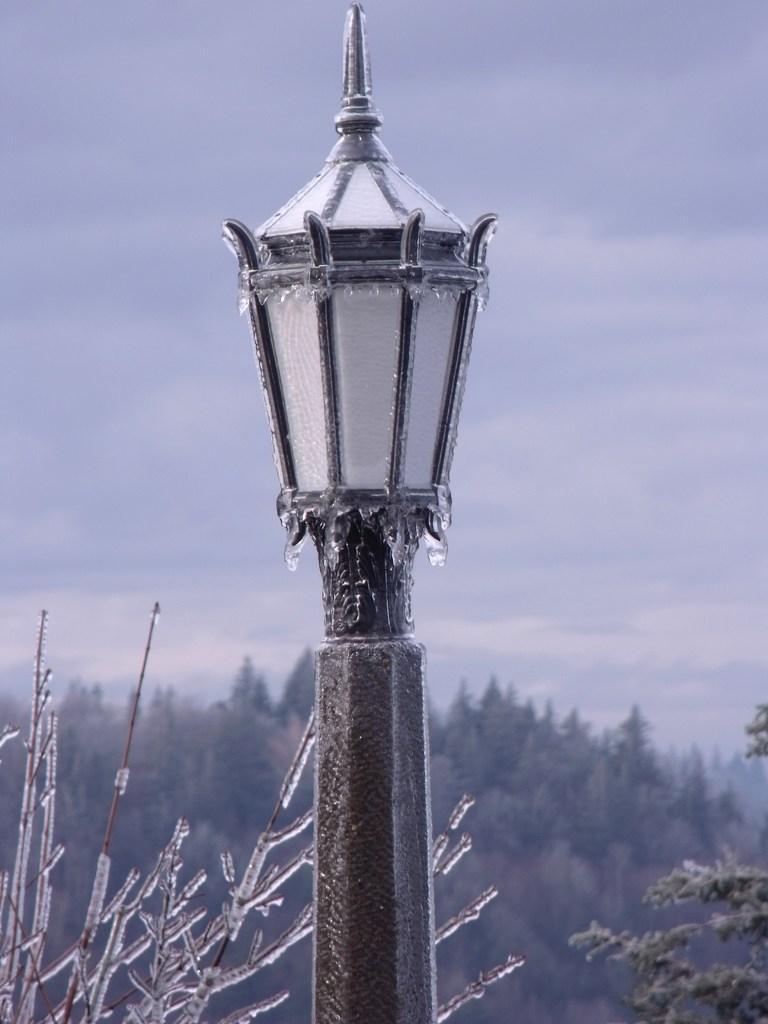Can you describe this image briefly? In the image we can see there is a street light pole which is covered with snow and there are plants which are covered with snow. Behind there are trees and the image is little blurry. 